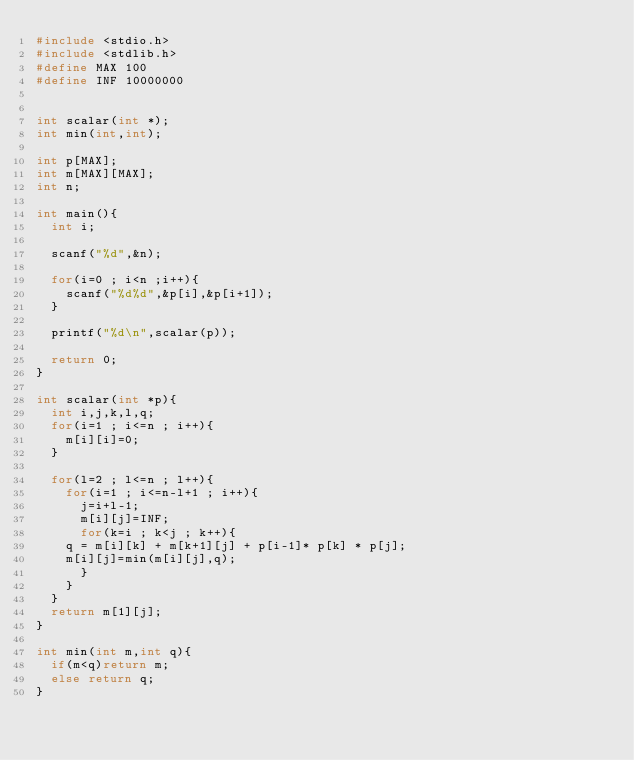Convert code to text. <code><loc_0><loc_0><loc_500><loc_500><_C_>#include <stdio.h>
#include <stdlib.h>
#define MAX 100
#define INF 10000000
 
 
int scalar(int *);
int min(int,int);
 
int p[MAX];
int m[MAX][MAX];
int n;
 
int main(){
  int i;
   
  scanf("%d",&n);
   
  for(i=0 ; i<n ;i++){
    scanf("%d%d",&p[i],&p[i+1]);
  }
 
  printf("%d\n",scalar(p));
   
  return 0;
}
 
int scalar(int *p){
  int i,j,k,l,q;
  for(i=1 ; i<=n ; i++){
    m[i][i]=0;
  }
 
  for(l=2 ; l<=n ; l++){
    for(i=1 ; i<=n-l+1 ; i++){
      j=i+l-1;
      m[i][j]=INF;
      for(k=i ; k<j ; k++){
    q = m[i][k] + m[k+1][j] + p[i-1]* p[k] * p[j];
    m[i][j]=min(m[i][j],q);
      }     
    }
  }
  return m[1][j];
}
 
int min(int m,int q){
  if(m<q)return m;
  else return q;
}</code> 